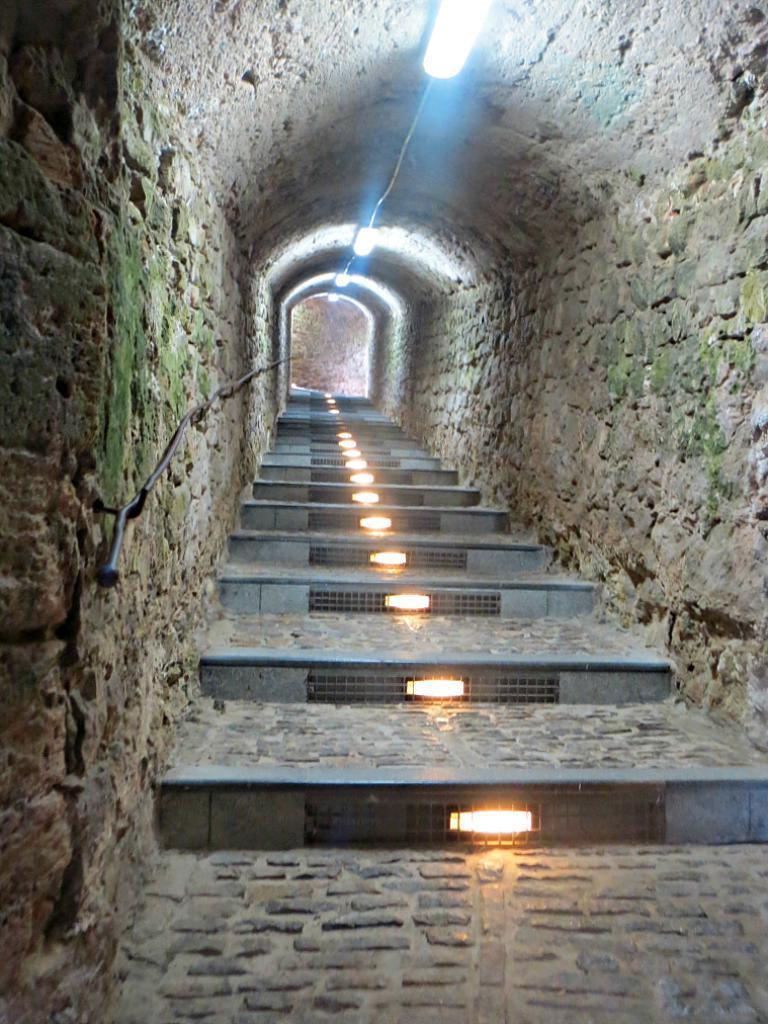Can you describe this image briefly? In the image there is a subway and inside the subway there are steps and there are lights fit to the roof of the subway. 